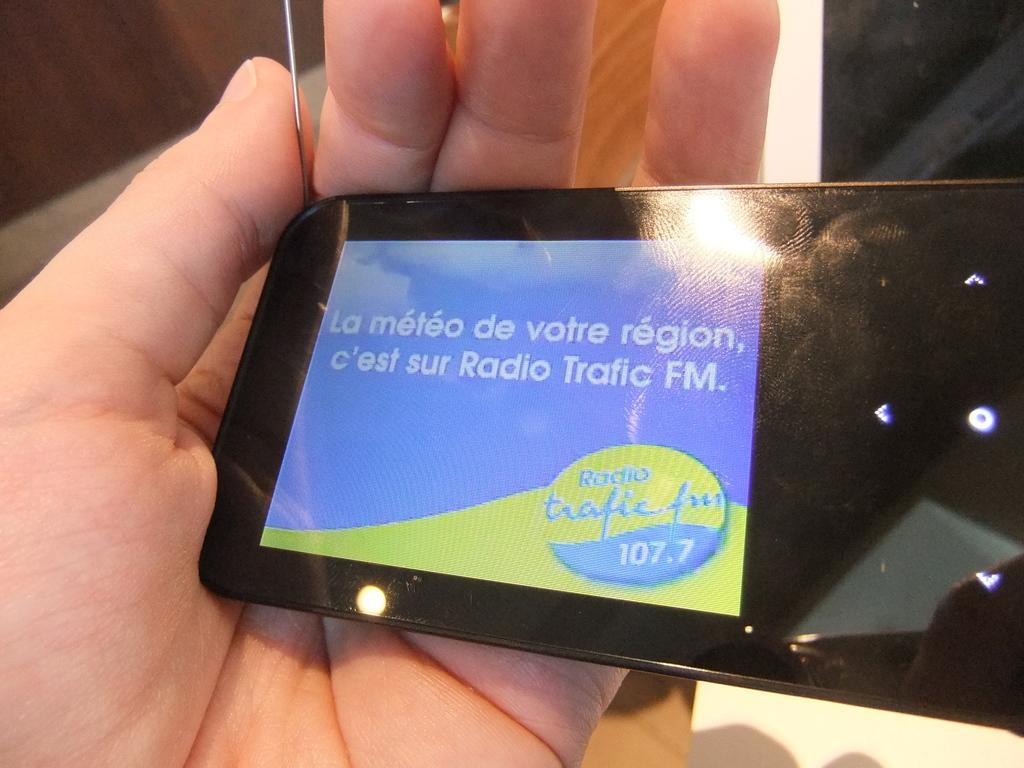Provide a one-sentence caption for the provided image. Person holding a device that says 107.7 on it. 